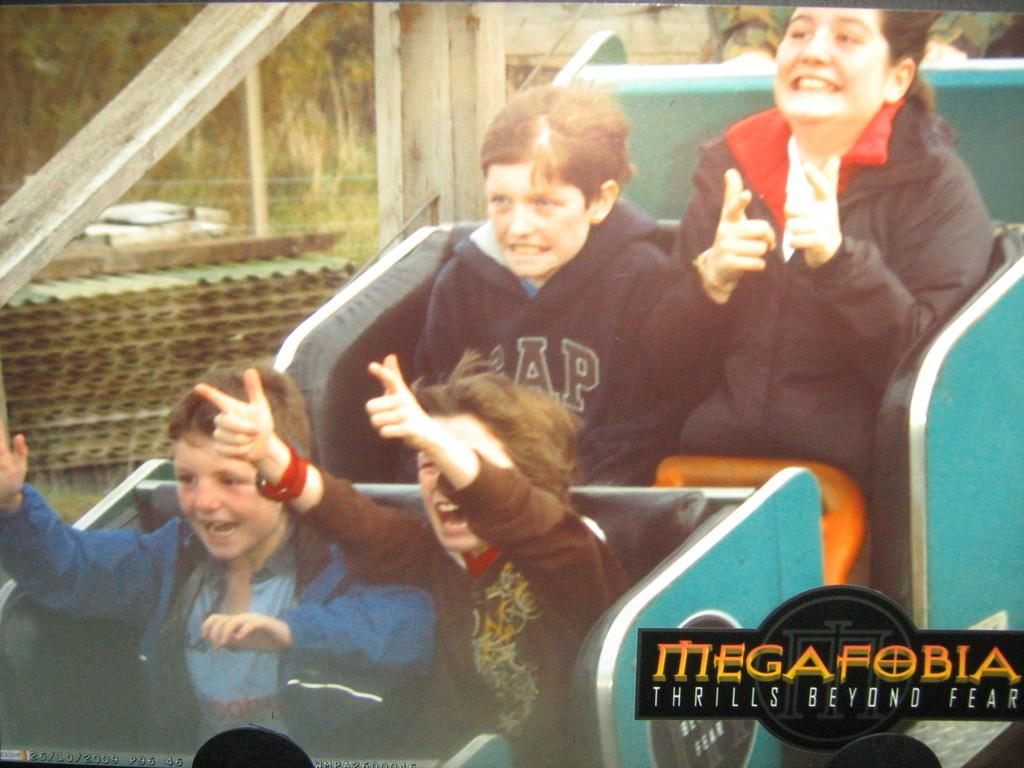How many people are in the image? There are four persons in the image. What are the persons doing in the image? The persons are seated. What can be seen in the background of the image? There are trees in the background of the image. What type of stamp can be seen on the person's forehead in the image? There is no stamp present on anyone's forehead in the image. 